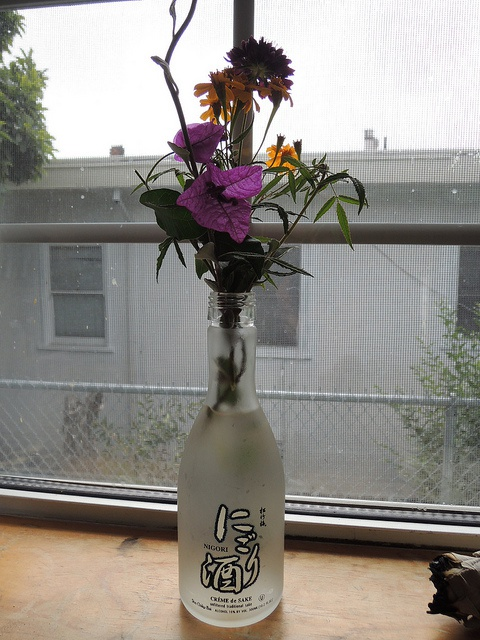Describe the objects in this image and their specific colors. I can see bottle in black, gray, and darkgray tones and potted plant in black and gray tones in this image. 